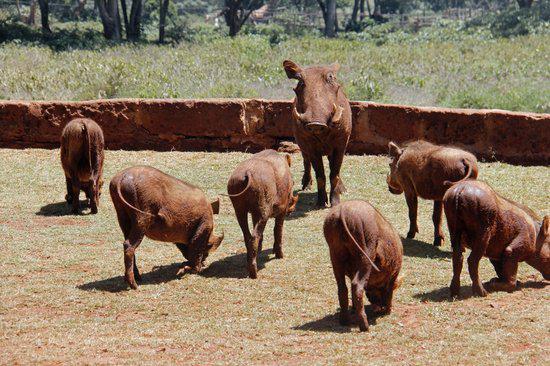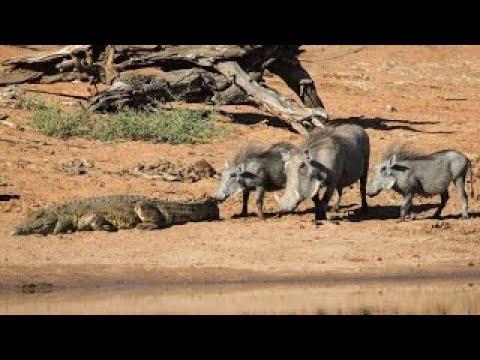The first image is the image on the left, the second image is the image on the right. For the images shown, is this caption "There is more than one kind of animal in the images." true? Answer yes or no. Yes. The first image is the image on the left, the second image is the image on the right. Evaluate the accuracy of this statement regarding the images: "There is at least one person in one of the pictures.". Is it true? Answer yes or no. No. 